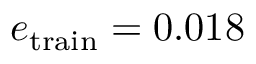<formula> <loc_0><loc_0><loc_500><loc_500>e _ { t r a i n } = 0 . 0 1 8</formula> 